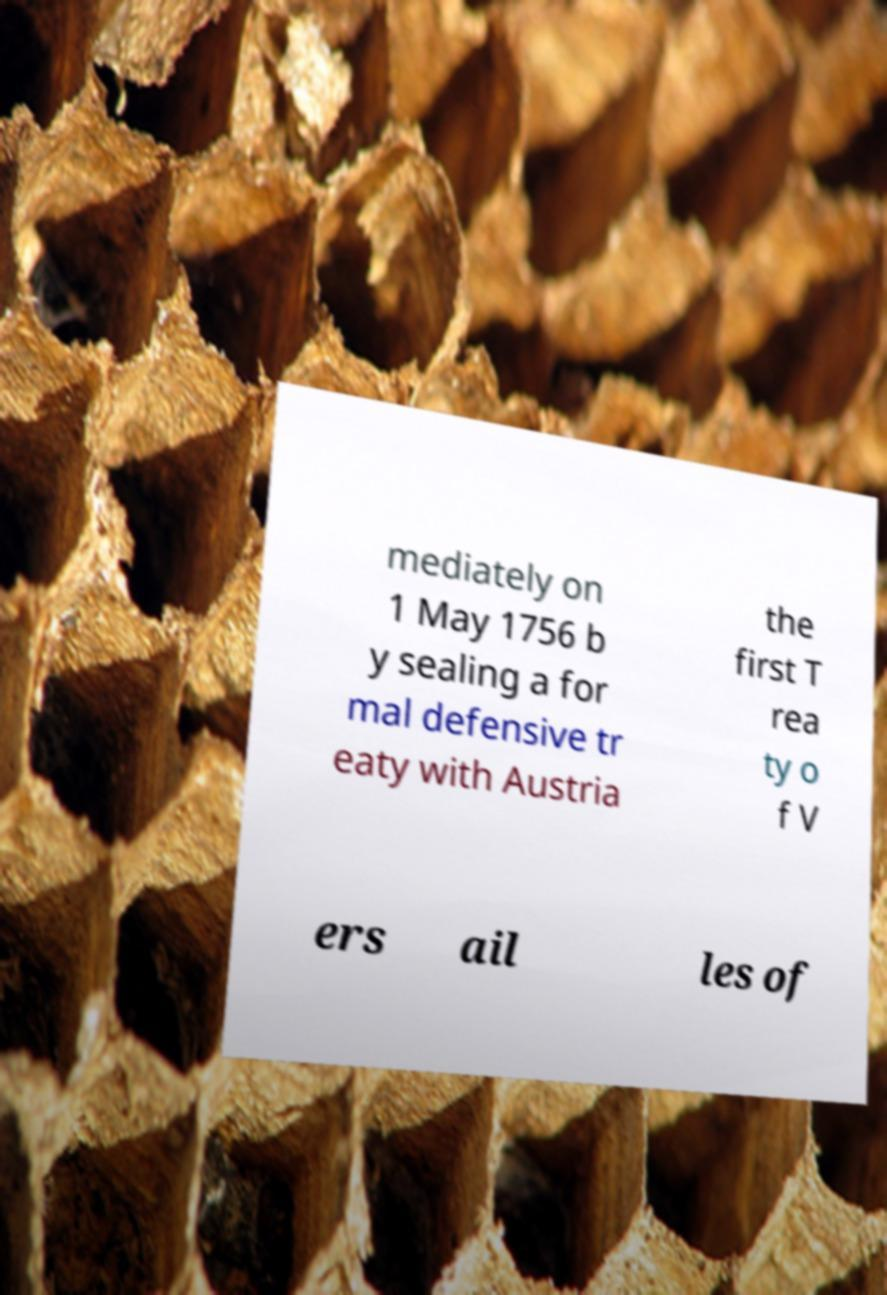Could you assist in decoding the text presented in this image and type it out clearly? mediately on 1 May 1756 b y sealing a for mal defensive tr eaty with Austria the first T rea ty o f V ers ail les of 